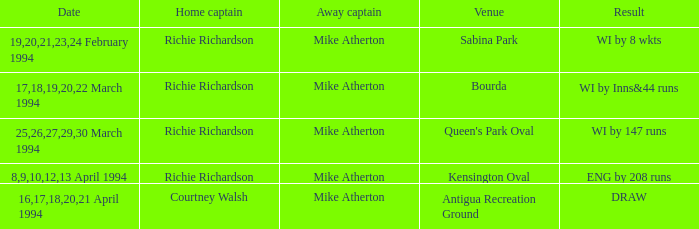Parse the full table. {'header': ['Date', 'Home captain', 'Away captain', 'Venue', 'Result'], 'rows': [['19,20,21,23,24 February 1994', 'Richie Richardson', 'Mike Atherton', 'Sabina Park', 'WI by 8 wkts'], ['17,18,19,20,22 March 1994', 'Richie Richardson', 'Mike Atherton', 'Bourda', 'WI by Inns&44 runs'], ['25,26,27,29,30 March 1994', 'Richie Richardson', 'Mike Atherton', "Queen's Park Oval", 'WI by 147 runs'], ['8,9,10,12,13 April 1994', 'Richie Richardson', 'Mike Atherton', 'Kensington Oval', 'ENG by 208 runs'], ['16,17,18,20,21 April 1994', 'Courtney Walsh', 'Mike Atherton', 'Antigua Recreation Ground', 'DRAW']]} Which Home Captain has Venue of Bourda? Richie Richardson. 